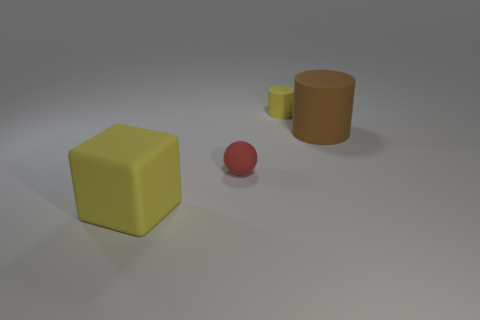Subtract all gray cylinders. Subtract all gray balls. How many cylinders are left? 2 Add 4 big yellow blocks. How many objects exist? 8 Subtract all cubes. How many objects are left? 3 Subtract all big cyan things. Subtract all tiny red matte balls. How many objects are left? 3 Add 3 cylinders. How many cylinders are left? 5 Add 4 large brown objects. How many large brown objects exist? 5 Subtract 0 cyan cylinders. How many objects are left? 4 